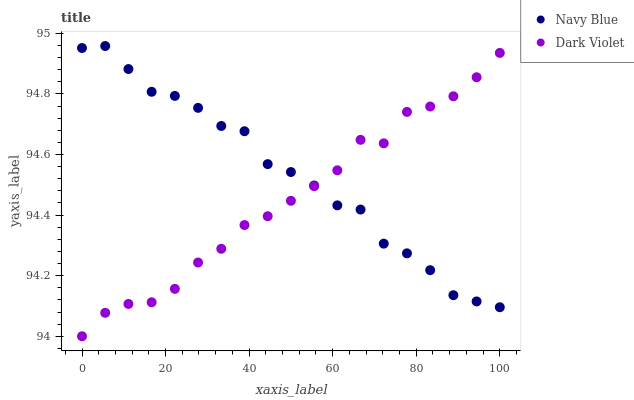Does Dark Violet have the minimum area under the curve?
Answer yes or no. Yes. Does Navy Blue have the maximum area under the curve?
Answer yes or no. Yes. Does Dark Violet have the maximum area under the curve?
Answer yes or no. No. Is Dark Violet the smoothest?
Answer yes or no. Yes. Is Navy Blue the roughest?
Answer yes or no. Yes. Is Dark Violet the roughest?
Answer yes or no. No. Does Dark Violet have the lowest value?
Answer yes or no. Yes. Does Navy Blue have the highest value?
Answer yes or no. Yes. Does Dark Violet have the highest value?
Answer yes or no. No. Does Navy Blue intersect Dark Violet?
Answer yes or no. Yes. Is Navy Blue less than Dark Violet?
Answer yes or no. No. Is Navy Blue greater than Dark Violet?
Answer yes or no. No. 